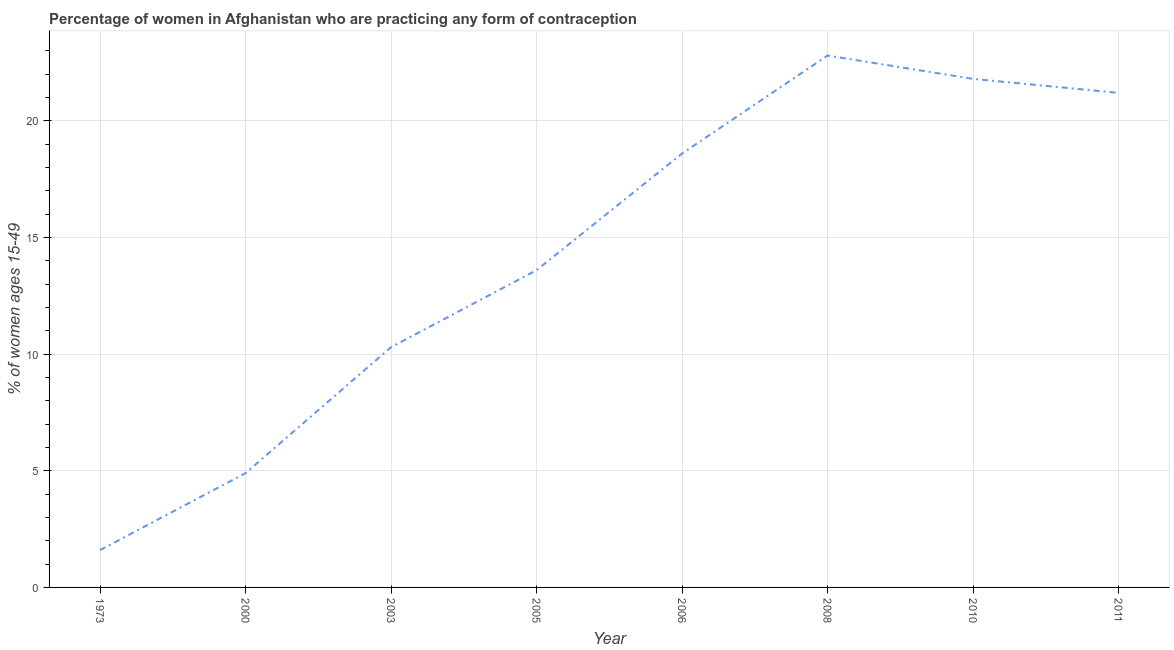What is the contraceptive prevalence in 2010?
Your answer should be compact. 21.8. Across all years, what is the maximum contraceptive prevalence?
Ensure brevity in your answer.  22.8. Across all years, what is the minimum contraceptive prevalence?
Your answer should be compact. 1.6. What is the sum of the contraceptive prevalence?
Your response must be concise. 114.8. What is the average contraceptive prevalence per year?
Give a very brief answer. 14.35. What is the median contraceptive prevalence?
Your answer should be very brief. 16.1. What is the ratio of the contraceptive prevalence in 1973 to that in 2005?
Provide a succinct answer. 0.12. Is the contraceptive prevalence in 1973 less than that in 2003?
Keep it short and to the point. Yes. What is the difference between the highest and the second highest contraceptive prevalence?
Offer a very short reply. 1. Is the sum of the contraceptive prevalence in 1973 and 2011 greater than the maximum contraceptive prevalence across all years?
Offer a terse response. No. What is the difference between the highest and the lowest contraceptive prevalence?
Your answer should be compact. 21.2. In how many years, is the contraceptive prevalence greater than the average contraceptive prevalence taken over all years?
Give a very brief answer. 4. How many lines are there?
Provide a short and direct response. 1. How many years are there in the graph?
Give a very brief answer. 8. What is the difference between two consecutive major ticks on the Y-axis?
Your answer should be compact. 5. Does the graph contain grids?
Ensure brevity in your answer.  Yes. What is the title of the graph?
Ensure brevity in your answer.  Percentage of women in Afghanistan who are practicing any form of contraception. What is the label or title of the X-axis?
Your response must be concise. Year. What is the label or title of the Y-axis?
Ensure brevity in your answer.  % of women ages 15-49. What is the % of women ages 15-49 of 1973?
Give a very brief answer. 1.6. What is the % of women ages 15-49 in 2000?
Make the answer very short. 4.9. What is the % of women ages 15-49 of 2005?
Ensure brevity in your answer.  13.6. What is the % of women ages 15-49 of 2006?
Give a very brief answer. 18.6. What is the % of women ages 15-49 in 2008?
Offer a terse response. 22.8. What is the % of women ages 15-49 in 2010?
Your answer should be very brief. 21.8. What is the % of women ages 15-49 in 2011?
Provide a short and direct response. 21.2. What is the difference between the % of women ages 15-49 in 1973 and 2000?
Give a very brief answer. -3.3. What is the difference between the % of women ages 15-49 in 1973 and 2006?
Provide a short and direct response. -17. What is the difference between the % of women ages 15-49 in 1973 and 2008?
Offer a terse response. -21.2. What is the difference between the % of women ages 15-49 in 1973 and 2010?
Ensure brevity in your answer.  -20.2. What is the difference between the % of women ages 15-49 in 1973 and 2011?
Provide a succinct answer. -19.6. What is the difference between the % of women ages 15-49 in 2000 and 2006?
Provide a succinct answer. -13.7. What is the difference between the % of women ages 15-49 in 2000 and 2008?
Keep it short and to the point. -17.9. What is the difference between the % of women ages 15-49 in 2000 and 2010?
Your answer should be very brief. -16.9. What is the difference between the % of women ages 15-49 in 2000 and 2011?
Offer a very short reply. -16.3. What is the difference between the % of women ages 15-49 in 2003 and 2005?
Provide a short and direct response. -3.3. What is the difference between the % of women ages 15-49 in 2003 and 2008?
Offer a very short reply. -12.5. What is the difference between the % of women ages 15-49 in 2003 and 2010?
Provide a short and direct response. -11.5. What is the difference between the % of women ages 15-49 in 2003 and 2011?
Provide a short and direct response. -10.9. What is the difference between the % of women ages 15-49 in 2005 and 2010?
Offer a terse response. -8.2. What is the difference between the % of women ages 15-49 in 2006 and 2010?
Your answer should be very brief. -3.2. What is the difference between the % of women ages 15-49 in 2006 and 2011?
Your response must be concise. -2.6. What is the difference between the % of women ages 15-49 in 2010 and 2011?
Offer a very short reply. 0.6. What is the ratio of the % of women ages 15-49 in 1973 to that in 2000?
Your answer should be compact. 0.33. What is the ratio of the % of women ages 15-49 in 1973 to that in 2003?
Make the answer very short. 0.15. What is the ratio of the % of women ages 15-49 in 1973 to that in 2005?
Give a very brief answer. 0.12. What is the ratio of the % of women ages 15-49 in 1973 to that in 2006?
Offer a very short reply. 0.09. What is the ratio of the % of women ages 15-49 in 1973 to that in 2008?
Offer a terse response. 0.07. What is the ratio of the % of women ages 15-49 in 1973 to that in 2010?
Ensure brevity in your answer.  0.07. What is the ratio of the % of women ages 15-49 in 1973 to that in 2011?
Offer a terse response. 0.07. What is the ratio of the % of women ages 15-49 in 2000 to that in 2003?
Ensure brevity in your answer.  0.48. What is the ratio of the % of women ages 15-49 in 2000 to that in 2005?
Offer a terse response. 0.36. What is the ratio of the % of women ages 15-49 in 2000 to that in 2006?
Your answer should be very brief. 0.26. What is the ratio of the % of women ages 15-49 in 2000 to that in 2008?
Your response must be concise. 0.21. What is the ratio of the % of women ages 15-49 in 2000 to that in 2010?
Give a very brief answer. 0.23. What is the ratio of the % of women ages 15-49 in 2000 to that in 2011?
Provide a short and direct response. 0.23. What is the ratio of the % of women ages 15-49 in 2003 to that in 2005?
Keep it short and to the point. 0.76. What is the ratio of the % of women ages 15-49 in 2003 to that in 2006?
Ensure brevity in your answer.  0.55. What is the ratio of the % of women ages 15-49 in 2003 to that in 2008?
Offer a very short reply. 0.45. What is the ratio of the % of women ages 15-49 in 2003 to that in 2010?
Provide a succinct answer. 0.47. What is the ratio of the % of women ages 15-49 in 2003 to that in 2011?
Offer a very short reply. 0.49. What is the ratio of the % of women ages 15-49 in 2005 to that in 2006?
Provide a short and direct response. 0.73. What is the ratio of the % of women ages 15-49 in 2005 to that in 2008?
Your answer should be compact. 0.6. What is the ratio of the % of women ages 15-49 in 2005 to that in 2010?
Offer a terse response. 0.62. What is the ratio of the % of women ages 15-49 in 2005 to that in 2011?
Offer a terse response. 0.64. What is the ratio of the % of women ages 15-49 in 2006 to that in 2008?
Offer a terse response. 0.82. What is the ratio of the % of women ages 15-49 in 2006 to that in 2010?
Give a very brief answer. 0.85. What is the ratio of the % of women ages 15-49 in 2006 to that in 2011?
Keep it short and to the point. 0.88. What is the ratio of the % of women ages 15-49 in 2008 to that in 2010?
Make the answer very short. 1.05. What is the ratio of the % of women ages 15-49 in 2008 to that in 2011?
Your response must be concise. 1.07. What is the ratio of the % of women ages 15-49 in 2010 to that in 2011?
Keep it short and to the point. 1.03. 